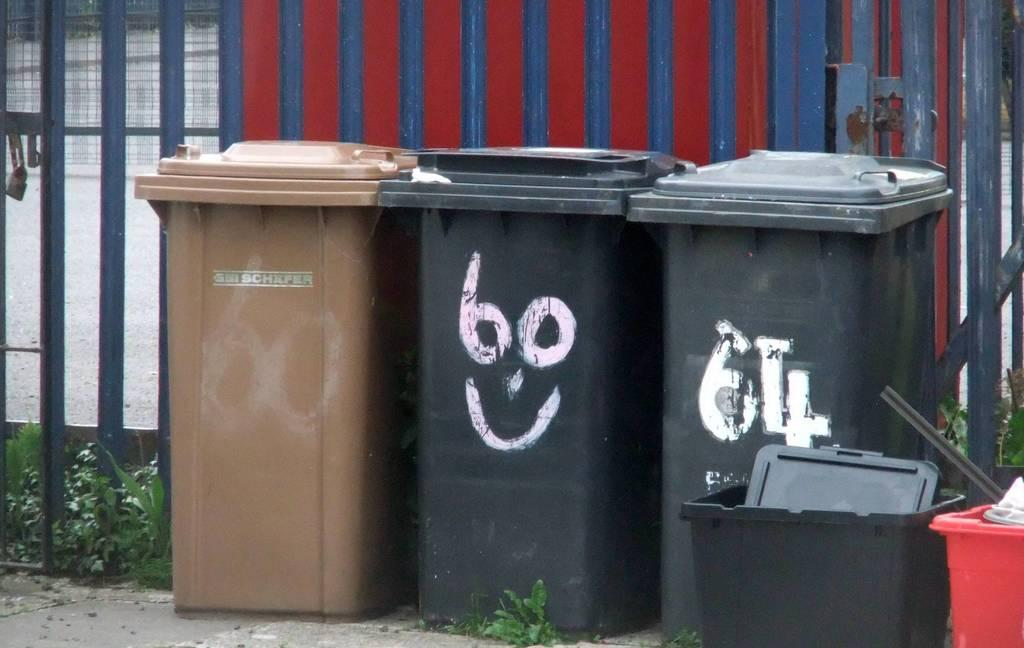Provide a one-sentence caption for the provided image. Three trash receptacles, 2 black and 1 brown. 